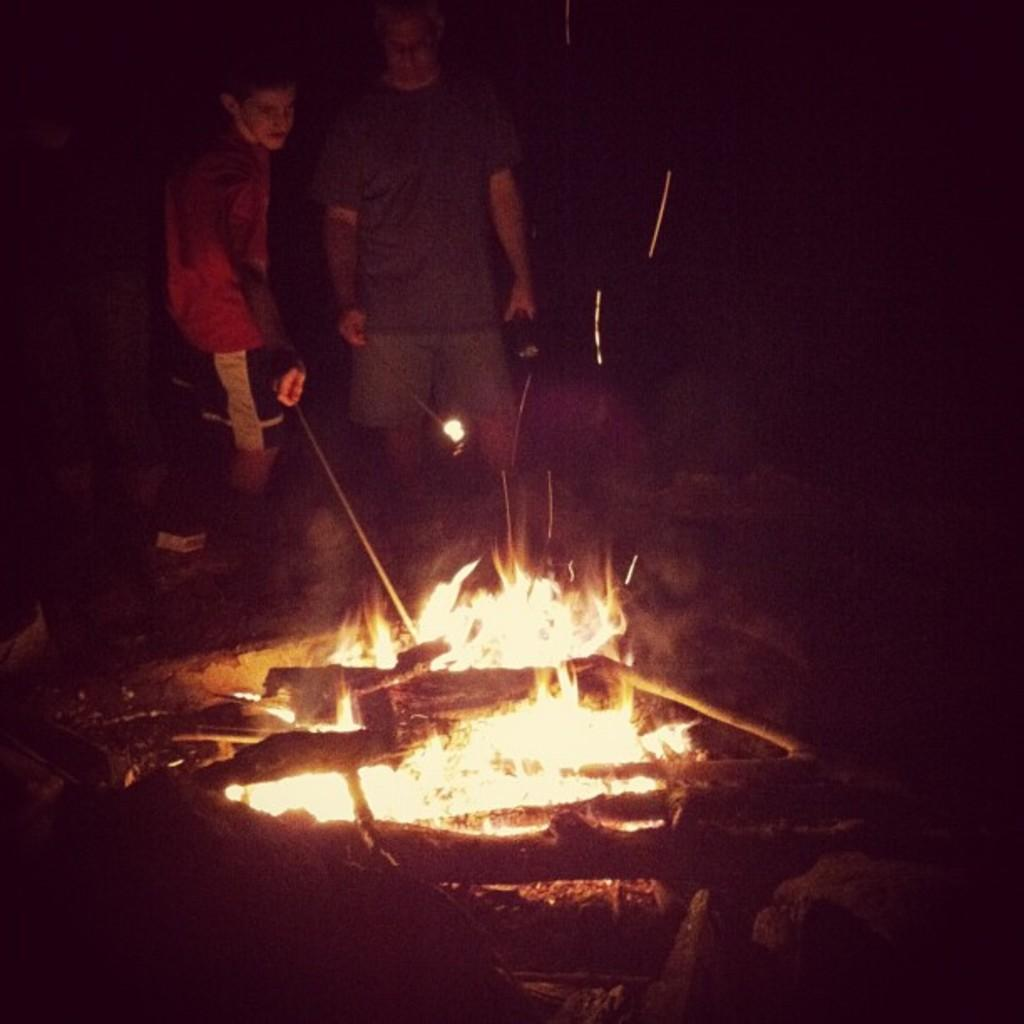How many people are in the image? There are people in the image, but the exact number is not specified. What are the people in the image doing? The people are standing in front of a fire. What direction is the wind blowing in the image? There is no mention of wind in the image, so it cannot be determined from the picture. Can you confirm the existence of a star in the image? There is no mention of a star in the image, so it cannot be confirmed. 